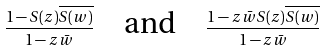<formula> <loc_0><loc_0><loc_500><loc_500>\frac { 1 - S ( z ) \overline { S ( w ) } } { 1 - z \bar { w } } \quad \text {and} \quad \frac { 1 - z \bar { w } S ( z ) \overline { S ( w ) } } { 1 - z \bar { w } }</formula> 